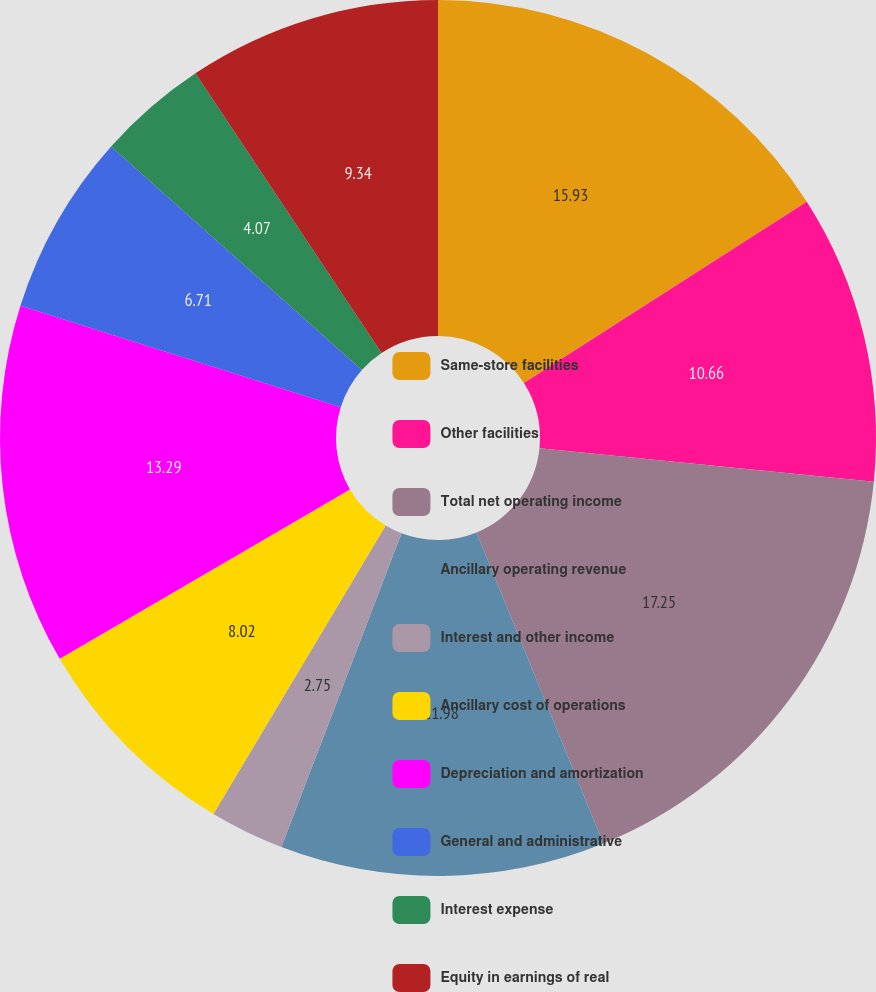Convert chart. <chart><loc_0><loc_0><loc_500><loc_500><pie_chart><fcel>Same-store facilities<fcel>Other facilities<fcel>Total net operating income<fcel>Ancillary operating revenue<fcel>Interest and other income<fcel>Ancillary cost of operations<fcel>Depreciation and amortization<fcel>General and administrative<fcel>Interest expense<fcel>Equity in earnings of real<nl><fcel>15.93%<fcel>10.66%<fcel>17.25%<fcel>11.98%<fcel>2.75%<fcel>8.02%<fcel>13.29%<fcel>6.71%<fcel>4.07%<fcel>9.34%<nl></chart> 